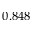<formula> <loc_0><loc_0><loc_500><loc_500>0 . 8 4 8</formula> 